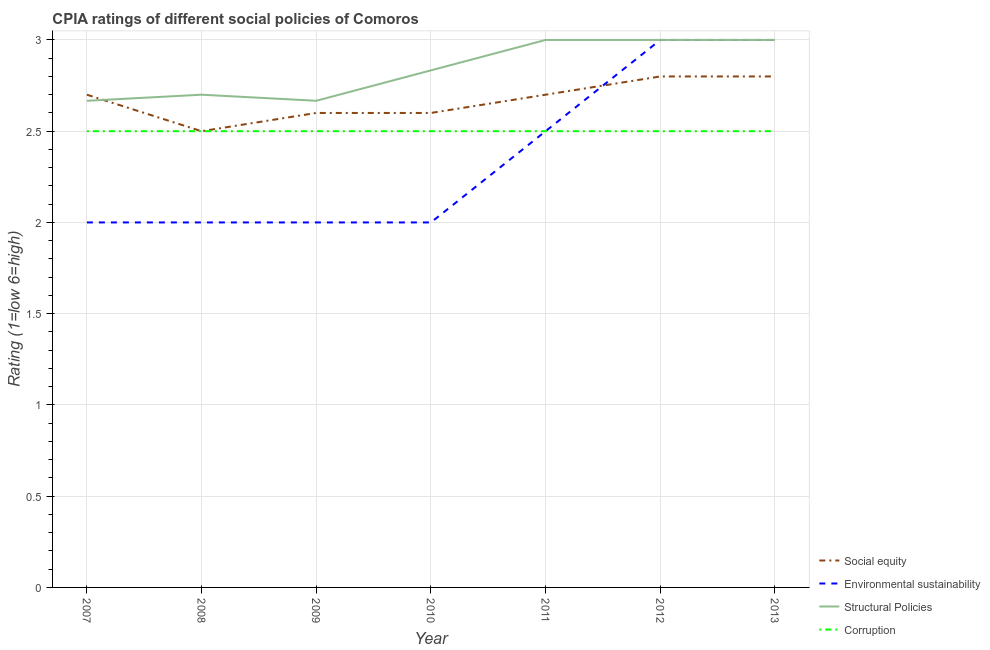How many different coloured lines are there?
Offer a very short reply. 4. Across all years, what is the maximum cpia rating of structural policies?
Offer a terse response. 3. Across all years, what is the minimum cpia rating of structural policies?
Offer a very short reply. 2.67. In which year was the cpia rating of environmental sustainability maximum?
Your answer should be very brief. 2012. What is the total cpia rating of structural policies in the graph?
Make the answer very short. 19.87. What is the difference between the cpia rating of environmental sustainability in 2010 and the cpia rating of social equity in 2013?
Ensure brevity in your answer.  -0.8. What is the average cpia rating of environmental sustainability per year?
Offer a very short reply. 2.36. What is the ratio of the cpia rating of environmental sustainability in 2009 to that in 2012?
Give a very brief answer. 0.67. Is the cpia rating of corruption in 2007 less than that in 2013?
Give a very brief answer. No. Is the difference between the cpia rating of environmental sustainability in 2009 and 2012 greater than the difference between the cpia rating of structural policies in 2009 and 2012?
Your answer should be compact. No. What is the difference between the highest and the second highest cpia rating of social equity?
Provide a short and direct response. 0. In how many years, is the cpia rating of corruption greater than the average cpia rating of corruption taken over all years?
Provide a succinct answer. 0. Is it the case that in every year, the sum of the cpia rating of structural policies and cpia rating of environmental sustainability is greater than the sum of cpia rating of social equity and cpia rating of corruption?
Your answer should be very brief. No. Does the cpia rating of corruption monotonically increase over the years?
Offer a very short reply. No. Is the cpia rating of environmental sustainability strictly less than the cpia rating of social equity over the years?
Provide a short and direct response. No. Does the graph contain any zero values?
Provide a short and direct response. No. Does the graph contain grids?
Offer a terse response. Yes. Where does the legend appear in the graph?
Your response must be concise. Bottom right. How are the legend labels stacked?
Keep it short and to the point. Vertical. What is the title of the graph?
Provide a succinct answer. CPIA ratings of different social policies of Comoros. What is the label or title of the X-axis?
Provide a succinct answer. Year. What is the Rating (1=low 6=high) in Environmental sustainability in 2007?
Offer a terse response. 2. What is the Rating (1=low 6=high) in Structural Policies in 2007?
Make the answer very short. 2.67. What is the Rating (1=low 6=high) in Social equity in 2008?
Your answer should be very brief. 2.5. What is the Rating (1=low 6=high) in Environmental sustainability in 2008?
Provide a short and direct response. 2. What is the Rating (1=low 6=high) in Structural Policies in 2008?
Give a very brief answer. 2.7. What is the Rating (1=low 6=high) of Social equity in 2009?
Provide a succinct answer. 2.6. What is the Rating (1=low 6=high) of Structural Policies in 2009?
Your answer should be compact. 2.67. What is the Rating (1=low 6=high) of Environmental sustainability in 2010?
Your response must be concise. 2. What is the Rating (1=low 6=high) of Structural Policies in 2010?
Your answer should be compact. 2.83. What is the Rating (1=low 6=high) of Corruption in 2010?
Keep it short and to the point. 2.5. What is the Rating (1=low 6=high) in Social equity in 2012?
Provide a short and direct response. 2.8. What is the Rating (1=low 6=high) in Structural Policies in 2012?
Provide a short and direct response. 3. What is the Rating (1=low 6=high) of Corruption in 2012?
Offer a terse response. 2.5. What is the Rating (1=low 6=high) of Environmental sustainability in 2013?
Your response must be concise. 3. What is the Rating (1=low 6=high) of Corruption in 2013?
Give a very brief answer. 2.5. Across all years, what is the maximum Rating (1=low 6=high) of Social equity?
Offer a terse response. 2.8. Across all years, what is the maximum Rating (1=low 6=high) of Environmental sustainability?
Give a very brief answer. 3. Across all years, what is the maximum Rating (1=low 6=high) in Corruption?
Provide a succinct answer. 2.5. Across all years, what is the minimum Rating (1=low 6=high) of Social equity?
Make the answer very short. 2.5. Across all years, what is the minimum Rating (1=low 6=high) in Structural Policies?
Offer a terse response. 2.67. Across all years, what is the minimum Rating (1=low 6=high) in Corruption?
Give a very brief answer. 2.5. What is the total Rating (1=low 6=high) of Structural Policies in the graph?
Your answer should be very brief. 19.87. What is the total Rating (1=low 6=high) in Corruption in the graph?
Your answer should be very brief. 17.5. What is the difference between the Rating (1=low 6=high) of Social equity in 2007 and that in 2008?
Provide a succinct answer. 0.2. What is the difference between the Rating (1=low 6=high) of Environmental sustainability in 2007 and that in 2008?
Give a very brief answer. 0. What is the difference between the Rating (1=low 6=high) in Structural Policies in 2007 and that in 2008?
Make the answer very short. -0.03. What is the difference between the Rating (1=low 6=high) of Corruption in 2007 and that in 2008?
Offer a terse response. 0. What is the difference between the Rating (1=low 6=high) of Social equity in 2007 and that in 2009?
Make the answer very short. 0.1. What is the difference between the Rating (1=low 6=high) in Structural Policies in 2007 and that in 2009?
Your answer should be very brief. 0. What is the difference between the Rating (1=low 6=high) in Corruption in 2007 and that in 2010?
Offer a very short reply. 0. What is the difference between the Rating (1=low 6=high) of Social equity in 2007 and that in 2012?
Your answer should be very brief. -0.1. What is the difference between the Rating (1=low 6=high) of Social equity in 2007 and that in 2013?
Provide a succinct answer. -0.1. What is the difference between the Rating (1=low 6=high) in Structural Policies in 2007 and that in 2013?
Your answer should be very brief. -0.33. What is the difference between the Rating (1=low 6=high) in Corruption in 2007 and that in 2013?
Your answer should be compact. 0. What is the difference between the Rating (1=low 6=high) of Environmental sustainability in 2008 and that in 2009?
Give a very brief answer. 0. What is the difference between the Rating (1=low 6=high) of Structural Policies in 2008 and that in 2009?
Your response must be concise. 0.03. What is the difference between the Rating (1=low 6=high) of Corruption in 2008 and that in 2009?
Your response must be concise. 0. What is the difference between the Rating (1=low 6=high) of Structural Policies in 2008 and that in 2010?
Your answer should be very brief. -0.13. What is the difference between the Rating (1=low 6=high) of Environmental sustainability in 2008 and that in 2011?
Your response must be concise. -0.5. What is the difference between the Rating (1=low 6=high) of Environmental sustainability in 2008 and that in 2012?
Keep it short and to the point. -1. What is the difference between the Rating (1=low 6=high) in Structural Policies in 2008 and that in 2012?
Your response must be concise. -0.3. What is the difference between the Rating (1=low 6=high) in Corruption in 2008 and that in 2012?
Your answer should be compact. 0. What is the difference between the Rating (1=low 6=high) of Social equity in 2008 and that in 2013?
Give a very brief answer. -0.3. What is the difference between the Rating (1=low 6=high) in Environmental sustainability in 2008 and that in 2013?
Give a very brief answer. -1. What is the difference between the Rating (1=low 6=high) of Corruption in 2008 and that in 2013?
Offer a terse response. 0. What is the difference between the Rating (1=low 6=high) in Social equity in 2009 and that in 2010?
Offer a very short reply. 0. What is the difference between the Rating (1=low 6=high) of Social equity in 2009 and that in 2011?
Keep it short and to the point. -0.1. What is the difference between the Rating (1=low 6=high) in Environmental sustainability in 2009 and that in 2011?
Offer a very short reply. -0.5. What is the difference between the Rating (1=low 6=high) in Social equity in 2009 and that in 2012?
Make the answer very short. -0.2. What is the difference between the Rating (1=low 6=high) of Structural Policies in 2009 and that in 2012?
Provide a short and direct response. -0.33. What is the difference between the Rating (1=low 6=high) of Corruption in 2009 and that in 2012?
Ensure brevity in your answer.  0. What is the difference between the Rating (1=low 6=high) of Environmental sustainability in 2009 and that in 2013?
Provide a succinct answer. -1. What is the difference between the Rating (1=low 6=high) in Corruption in 2009 and that in 2013?
Ensure brevity in your answer.  0. What is the difference between the Rating (1=low 6=high) of Structural Policies in 2010 and that in 2011?
Your answer should be very brief. -0.17. What is the difference between the Rating (1=low 6=high) in Corruption in 2010 and that in 2011?
Offer a terse response. 0. What is the difference between the Rating (1=low 6=high) in Environmental sustainability in 2010 and that in 2012?
Provide a short and direct response. -1. What is the difference between the Rating (1=low 6=high) in Corruption in 2010 and that in 2012?
Your response must be concise. 0. What is the difference between the Rating (1=low 6=high) of Social equity in 2010 and that in 2013?
Keep it short and to the point. -0.2. What is the difference between the Rating (1=low 6=high) in Environmental sustainability in 2010 and that in 2013?
Make the answer very short. -1. What is the difference between the Rating (1=low 6=high) in Corruption in 2010 and that in 2013?
Ensure brevity in your answer.  0. What is the difference between the Rating (1=low 6=high) in Social equity in 2011 and that in 2012?
Make the answer very short. -0.1. What is the difference between the Rating (1=low 6=high) in Environmental sustainability in 2011 and that in 2012?
Give a very brief answer. -0.5. What is the difference between the Rating (1=low 6=high) in Structural Policies in 2011 and that in 2013?
Give a very brief answer. 0. What is the difference between the Rating (1=low 6=high) in Social equity in 2012 and that in 2013?
Your response must be concise. 0. What is the difference between the Rating (1=low 6=high) in Structural Policies in 2012 and that in 2013?
Your answer should be compact. 0. What is the difference between the Rating (1=low 6=high) of Social equity in 2007 and the Rating (1=low 6=high) of Structural Policies in 2008?
Your answer should be very brief. 0. What is the difference between the Rating (1=low 6=high) of Structural Policies in 2007 and the Rating (1=low 6=high) of Corruption in 2008?
Keep it short and to the point. 0.17. What is the difference between the Rating (1=low 6=high) in Social equity in 2007 and the Rating (1=low 6=high) in Structural Policies in 2009?
Your answer should be very brief. 0.03. What is the difference between the Rating (1=low 6=high) in Environmental sustainability in 2007 and the Rating (1=low 6=high) in Structural Policies in 2009?
Offer a terse response. -0.67. What is the difference between the Rating (1=low 6=high) of Environmental sustainability in 2007 and the Rating (1=low 6=high) of Corruption in 2009?
Provide a succinct answer. -0.5. What is the difference between the Rating (1=low 6=high) in Social equity in 2007 and the Rating (1=low 6=high) in Environmental sustainability in 2010?
Offer a terse response. 0.7. What is the difference between the Rating (1=low 6=high) of Social equity in 2007 and the Rating (1=low 6=high) of Structural Policies in 2010?
Your response must be concise. -0.13. What is the difference between the Rating (1=low 6=high) of Social equity in 2007 and the Rating (1=low 6=high) of Environmental sustainability in 2011?
Your answer should be very brief. 0.2. What is the difference between the Rating (1=low 6=high) of Environmental sustainability in 2007 and the Rating (1=low 6=high) of Corruption in 2011?
Your answer should be very brief. -0.5. What is the difference between the Rating (1=low 6=high) of Social equity in 2007 and the Rating (1=low 6=high) of Structural Policies in 2012?
Make the answer very short. -0.3. What is the difference between the Rating (1=low 6=high) in Environmental sustainability in 2007 and the Rating (1=low 6=high) in Corruption in 2012?
Provide a short and direct response. -0.5. What is the difference between the Rating (1=low 6=high) in Structural Policies in 2007 and the Rating (1=low 6=high) in Corruption in 2012?
Your answer should be compact. 0.17. What is the difference between the Rating (1=low 6=high) of Social equity in 2007 and the Rating (1=low 6=high) of Environmental sustainability in 2013?
Offer a very short reply. -0.3. What is the difference between the Rating (1=low 6=high) of Social equity in 2007 and the Rating (1=low 6=high) of Corruption in 2013?
Ensure brevity in your answer.  0.2. What is the difference between the Rating (1=low 6=high) in Environmental sustainability in 2007 and the Rating (1=low 6=high) in Structural Policies in 2013?
Provide a short and direct response. -1. What is the difference between the Rating (1=low 6=high) in Environmental sustainability in 2007 and the Rating (1=low 6=high) in Corruption in 2013?
Make the answer very short. -0.5. What is the difference between the Rating (1=low 6=high) of Social equity in 2008 and the Rating (1=low 6=high) of Environmental sustainability in 2009?
Make the answer very short. 0.5. What is the difference between the Rating (1=low 6=high) of Social equity in 2008 and the Rating (1=low 6=high) of Structural Policies in 2010?
Ensure brevity in your answer.  -0.33. What is the difference between the Rating (1=low 6=high) in Environmental sustainability in 2008 and the Rating (1=low 6=high) in Corruption in 2010?
Make the answer very short. -0.5. What is the difference between the Rating (1=low 6=high) of Environmental sustainability in 2008 and the Rating (1=low 6=high) of Corruption in 2011?
Your answer should be very brief. -0.5. What is the difference between the Rating (1=low 6=high) in Social equity in 2008 and the Rating (1=low 6=high) in Environmental sustainability in 2012?
Your response must be concise. -0.5. What is the difference between the Rating (1=low 6=high) of Social equity in 2008 and the Rating (1=low 6=high) of Corruption in 2012?
Make the answer very short. 0. What is the difference between the Rating (1=low 6=high) of Environmental sustainability in 2008 and the Rating (1=low 6=high) of Structural Policies in 2012?
Give a very brief answer. -1. What is the difference between the Rating (1=low 6=high) in Environmental sustainability in 2008 and the Rating (1=low 6=high) in Corruption in 2012?
Keep it short and to the point. -0.5. What is the difference between the Rating (1=low 6=high) of Social equity in 2008 and the Rating (1=low 6=high) of Environmental sustainability in 2013?
Give a very brief answer. -0.5. What is the difference between the Rating (1=low 6=high) in Social equity in 2008 and the Rating (1=low 6=high) in Structural Policies in 2013?
Keep it short and to the point. -0.5. What is the difference between the Rating (1=low 6=high) in Social equity in 2008 and the Rating (1=low 6=high) in Corruption in 2013?
Your answer should be very brief. 0. What is the difference between the Rating (1=low 6=high) in Social equity in 2009 and the Rating (1=low 6=high) in Environmental sustainability in 2010?
Offer a very short reply. 0.6. What is the difference between the Rating (1=low 6=high) in Social equity in 2009 and the Rating (1=low 6=high) in Structural Policies in 2010?
Make the answer very short. -0.23. What is the difference between the Rating (1=low 6=high) of Social equity in 2009 and the Rating (1=low 6=high) of Corruption in 2010?
Your response must be concise. 0.1. What is the difference between the Rating (1=low 6=high) of Structural Policies in 2009 and the Rating (1=low 6=high) of Corruption in 2010?
Give a very brief answer. 0.17. What is the difference between the Rating (1=low 6=high) in Social equity in 2009 and the Rating (1=low 6=high) in Environmental sustainability in 2011?
Ensure brevity in your answer.  0.1. What is the difference between the Rating (1=low 6=high) in Social equity in 2009 and the Rating (1=low 6=high) in Environmental sustainability in 2012?
Give a very brief answer. -0.4. What is the difference between the Rating (1=low 6=high) in Social equity in 2009 and the Rating (1=low 6=high) in Structural Policies in 2012?
Your response must be concise. -0.4. What is the difference between the Rating (1=low 6=high) of Social equity in 2009 and the Rating (1=low 6=high) of Corruption in 2012?
Offer a very short reply. 0.1. What is the difference between the Rating (1=low 6=high) in Structural Policies in 2009 and the Rating (1=low 6=high) in Corruption in 2012?
Make the answer very short. 0.17. What is the difference between the Rating (1=low 6=high) of Social equity in 2009 and the Rating (1=low 6=high) of Environmental sustainability in 2013?
Offer a terse response. -0.4. What is the difference between the Rating (1=low 6=high) of Social equity in 2009 and the Rating (1=low 6=high) of Corruption in 2013?
Your answer should be compact. 0.1. What is the difference between the Rating (1=low 6=high) of Environmental sustainability in 2009 and the Rating (1=low 6=high) of Structural Policies in 2013?
Provide a short and direct response. -1. What is the difference between the Rating (1=low 6=high) in Environmental sustainability in 2009 and the Rating (1=low 6=high) in Corruption in 2013?
Your answer should be very brief. -0.5. What is the difference between the Rating (1=low 6=high) in Structural Policies in 2009 and the Rating (1=low 6=high) in Corruption in 2013?
Give a very brief answer. 0.17. What is the difference between the Rating (1=low 6=high) of Social equity in 2010 and the Rating (1=low 6=high) of Structural Policies in 2011?
Offer a very short reply. -0.4. What is the difference between the Rating (1=low 6=high) in Environmental sustainability in 2010 and the Rating (1=low 6=high) in Structural Policies in 2011?
Keep it short and to the point. -1. What is the difference between the Rating (1=low 6=high) in Structural Policies in 2010 and the Rating (1=low 6=high) in Corruption in 2011?
Offer a terse response. 0.33. What is the difference between the Rating (1=low 6=high) in Social equity in 2010 and the Rating (1=low 6=high) in Structural Policies in 2012?
Offer a very short reply. -0.4. What is the difference between the Rating (1=low 6=high) in Social equity in 2010 and the Rating (1=low 6=high) in Corruption in 2012?
Your response must be concise. 0.1. What is the difference between the Rating (1=low 6=high) in Environmental sustainability in 2010 and the Rating (1=low 6=high) in Structural Policies in 2012?
Offer a terse response. -1. What is the difference between the Rating (1=low 6=high) of Environmental sustainability in 2010 and the Rating (1=low 6=high) of Corruption in 2012?
Make the answer very short. -0.5. What is the difference between the Rating (1=low 6=high) of Social equity in 2010 and the Rating (1=low 6=high) of Corruption in 2013?
Your answer should be very brief. 0.1. What is the difference between the Rating (1=low 6=high) in Structural Policies in 2010 and the Rating (1=low 6=high) in Corruption in 2013?
Your response must be concise. 0.33. What is the difference between the Rating (1=low 6=high) in Social equity in 2011 and the Rating (1=low 6=high) in Environmental sustainability in 2012?
Your response must be concise. -0.3. What is the difference between the Rating (1=low 6=high) in Environmental sustainability in 2011 and the Rating (1=low 6=high) in Structural Policies in 2012?
Offer a terse response. -0.5. What is the difference between the Rating (1=low 6=high) of Structural Policies in 2011 and the Rating (1=low 6=high) of Corruption in 2012?
Give a very brief answer. 0.5. What is the difference between the Rating (1=low 6=high) in Social equity in 2011 and the Rating (1=low 6=high) in Environmental sustainability in 2013?
Your response must be concise. -0.3. What is the difference between the Rating (1=low 6=high) of Social equity in 2011 and the Rating (1=low 6=high) of Structural Policies in 2013?
Offer a terse response. -0.3. What is the difference between the Rating (1=low 6=high) of Structural Policies in 2011 and the Rating (1=low 6=high) of Corruption in 2013?
Offer a very short reply. 0.5. What is the difference between the Rating (1=low 6=high) of Environmental sustainability in 2012 and the Rating (1=low 6=high) of Structural Policies in 2013?
Make the answer very short. 0. What is the difference between the Rating (1=low 6=high) of Environmental sustainability in 2012 and the Rating (1=low 6=high) of Corruption in 2013?
Provide a succinct answer. 0.5. What is the average Rating (1=low 6=high) in Social equity per year?
Provide a short and direct response. 2.67. What is the average Rating (1=low 6=high) in Environmental sustainability per year?
Offer a terse response. 2.36. What is the average Rating (1=low 6=high) in Structural Policies per year?
Your answer should be compact. 2.84. In the year 2007, what is the difference between the Rating (1=low 6=high) of Social equity and Rating (1=low 6=high) of Environmental sustainability?
Your answer should be compact. 0.7. In the year 2007, what is the difference between the Rating (1=low 6=high) in Social equity and Rating (1=low 6=high) in Structural Policies?
Make the answer very short. 0.03. In the year 2007, what is the difference between the Rating (1=low 6=high) in Social equity and Rating (1=low 6=high) in Corruption?
Provide a short and direct response. 0.2. In the year 2008, what is the difference between the Rating (1=low 6=high) of Social equity and Rating (1=low 6=high) of Structural Policies?
Your response must be concise. -0.2. In the year 2008, what is the difference between the Rating (1=low 6=high) in Social equity and Rating (1=low 6=high) in Corruption?
Your answer should be very brief. 0. In the year 2008, what is the difference between the Rating (1=low 6=high) of Structural Policies and Rating (1=low 6=high) of Corruption?
Offer a terse response. 0.2. In the year 2009, what is the difference between the Rating (1=low 6=high) in Social equity and Rating (1=low 6=high) in Structural Policies?
Provide a succinct answer. -0.07. In the year 2009, what is the difference between the Rating (1=low 6=high) of Environmental sustainability and Rating (1=low 6=high) of Structural Policies?
Offer a very short reply. -0.67. In the year 2010, what is the difference between the Rating (1=low 6=high) in Social equity and Rating (1=low 6=high) in Environmental sustainability?
Offer a very short reply. 0.6. In the year 2010, what is the difference between the Rating (1=low 6=high) of Social equity and Rating (1=low 6=high) of Structural Policies?
Your answer should be compact. -0.23. In the year 2010, what is the difference between the Rating (1=low 6=high) of Environmental sustainability and Rating (1=low 6=high) of Structural Policies?
Your response must be concise. -0.83. In the year 2010, what is the difference between the Rating (1=low 6=high) in Environmental sustainability and Rating (1=low 6=high) in Corruption?
Ensure brevity in your answer.  -0.5. In the year 2011, what is the difference between the Rating (1=low 6=high) of Social equity and Rating (1=low 6=high) of Structural Policies?
Provide a short and direct response. -0.3. In the year 2011, what is the difference between the Rating (1=low 6=high) of Structural Policies and Rating (1=low 6=high) of Corruption?
Provide a short and direct response. 0.5. In the year 2012, what is the difference between the Rating (1=low 6=high) of Social equity and Rating (1=low 6=high) of Environmental sustainability?
Give a very brief answer. -0.2. In the year 2012, what is the difference between the Rating (1=low 6=high) of Social equity and Rating (1=low 6=high) of Structural Policies?
Offer a very short reply. -0.2. In the year 2012, what is the difference between the Rating (1=low 6=high) of Social equity and Rating (1=low 6=high) of Corruption?
Your response must be concise. 0.3. In the year 2012, what is the difference between the Rating (1=low 6=high) in Environmental sustainability and Rating (1=low 6=high) in Structural Policies?
Provide a short and direct response. 0. In the year 2012, what is the difference between the Rating (1=low 6=high) of Structural Policies and Rating (1=low 6=high) of Corruption?
Your answer should be very brief. 0.5. In the year 2013, what is the difference between the Rating (1=low 6=high) of Environmental sustainability and Rating (1=low 6=high) of Structural Policies?
Your answer should be compact. 0. In the year 2013, what is the difference between the Rating (1=low 6=high) in Structural Policies and Rating (1=low 6=high) in Corruption?
Keep it short and to the point. 0.5. What is the ratio of the Rating (1=low 6=high) in Environmental sustainability in 2007 to that in 2008?
Make the answer very short. 1. What is the ratio of the Rating (1=low 6=high) in Corruption in 2007 to that in 2008?
Provide a short and direct response. 1. What is the ratio of the Rating (1=low 6=high) in Structural Policies in 2007 to that in 2009?
Your answer should be very brief. 1. What is the ratio of the Rating (1=low 6=high) of Corruption in 2007 to that in 2009?
Provide a succinct answer. 1. What is the ratio of the Rating (1=low 6=high) in Structural Policies in 2007 to that in 2010?
Offer a very short reply. 0.94. What is the ratio of the Rating (1=low 6=high) of Environmental sustainability in 2007 to that in 2011?
Provide a succinct answer. 0.8. What is the ratio of the Rating (1=low 6=high) in Social equity in 2007 to that in 2012?
Your answer should be compact. 0.96. What is the ratio of the Rating (1=low 6=high) of Environmental sustainability in 2007 to that in 2012?
Ensure brevity in your answer.  0.67. What is the ratio of the Rating (1=low 6=high) in Structural Policies in 2007 to that in 2012?
Ensure brevity in your answer.  0.89. What is the ratio of the Rating (1=low 6=high) in Corruption in 2007 to that in 2013?
Your answer should be very brief. 1. What is the ratio of the Rating (1=low 6=high) of Social equity in 2008 to that in 2009?
Offer a very short reply. 0.96. What is the ratio of the Rating (1=low 6=high) in Environmental sustainability in 2008 to that in 2009?
Make the answer very short. 1. What is the ratio of the Rating (1=low 6=high) in Structural Policies in 2008 to that in 2009?
Keep it short and to the point. 1.01. What is the ratio of the Rating (1=low 6=high) of Social equity in 2008 to that in 2010?
Your answer should be compact. 0.96. What is the ratio of the Rating (1=low 6=high) of Environmental sustainability in 2008 to that in 2010?
Ensure brevity in your answer.  1. What is the ratio of the Rating (1=low 6=high) of Structural Policies in 2008 to that in 2010?
Keep it short and to the point. 0.95. What is the ratio of the Rating (1=low 6=high) of Corruption in 2008 to that in 2010?
Make the answer very short. 1. What is the ratio of the Rating (1=low 6=high) in Social equity in 2008 to that in 2011?
Offer a terse response. 0.93. What is the ratio of the Rating (1=low 6=high) of Social equity in 2008 to that in 2012?
Your response must be concise. 0.89. What is the ratio of the Rating (1=low 6=high) in Environmental sustainability in 2008 to that in 2012?
Make the answer very short. 0.67. What is the ratio of the Rating (1=low 6=high) in Structural Policies in 2008 to that in 2012?
Make the answer very short. 0.9. What is the ratio of the Rating (1=low 6=high) of Corruption in 2008 to that in 2012?
Your response must be concise. 1. What is the ratio of the Rating (1=low 6=high) in Social equity in 2008 to that in 2013?
Provide a succinct answer. 0.89. What is the ratio of the Rating (1=low 6=high) of Social equity in 2009 to that in 2010?
Provide a succinct answer. 1. What is the ratio of the Rating (1=low 6=high) of Structural Policies in 2009 to that in 2010?
Provide a short and direct response. 0.94. What is the ratio of the Rating (1=low 6=high) of Corruption in 2009 to that in 2011?
Provide a succinct answer. 1. What is the ratio of the Rating (1=low 6=high) of Social equity in 2009 to that in 2012?
Make the answer very short. 0.93. What is the ratio of the Rating (1=low 6=high) in Structural Policies in 2009 to that in 2012?
Offer a terse response. 0.89. What is the ratio of the Rating (1=low 6=high) of Corruption in 2009 to that in 2012?
Provide a succinct answer. 1. What is the ratio of the Rating (1=low 6=high) in Social equity in 2009 to that in 2013?
Offer a terse response. 0.93. What is the ratio of the Rating (1=low 6=high) in Structural Policies in 2010 to that in 2011?
Give a very brief answer. 0.94. What is the ratio of the Rating (1=low 6=high) in Environmental sustainability in 2010 to that in 2012?
Provide a short and direct response. 0.67. What is the ratio of the Rating (1=low 6=high) in Structural Policies in 2010 to that in 2012?
Provide a short and direct response. 0.94. What is the ratio of the Rating (1=low 6=high) of Corruption in 2010 to that in 2012?
Your answer should be very brief. 1. What is the ratio of the Rating (1=low 6=high) of Environmental sustainability in 2011 to that in 2012?
Make the answer very short. 0.83. What is the ratio of the Rating (1=low 6=high) in Social equity in 2011 to that in 2013?
Your response must be concise. 0.96. What is the ratio of the Rating (1=low 6=high) of Environmental sustainability in 2011 to that in 2013?
Provide a short and direct response. 0.83. What is the ratio of the Rating (1=low 6=high) in Structural Policies in 2011 to that in 2013?
Ensure brevity in your answer.  1. What is the ratio of the Rating (1=low 6=high) in Corruption in 2012 to that in 2013?
Make the answer very short. 1. What is the difference between the highest and the second highest Rating (1=low 6=high) in Social equity?
Offer a terse response. 0. What is the difference between the highest and the second highest Rating (1=low 6=high) of Environmental sustainability?
Make the answer very short. 0. What is the difference between the highest and the lowest Rating (1=low 6=high) in Social equity?
Your answer should be compact. 0.3. What is the difference between the highest and the lowest Rating (1=low 6=high) of Structural Policies?
Provide a succinct answer. 0.33. 